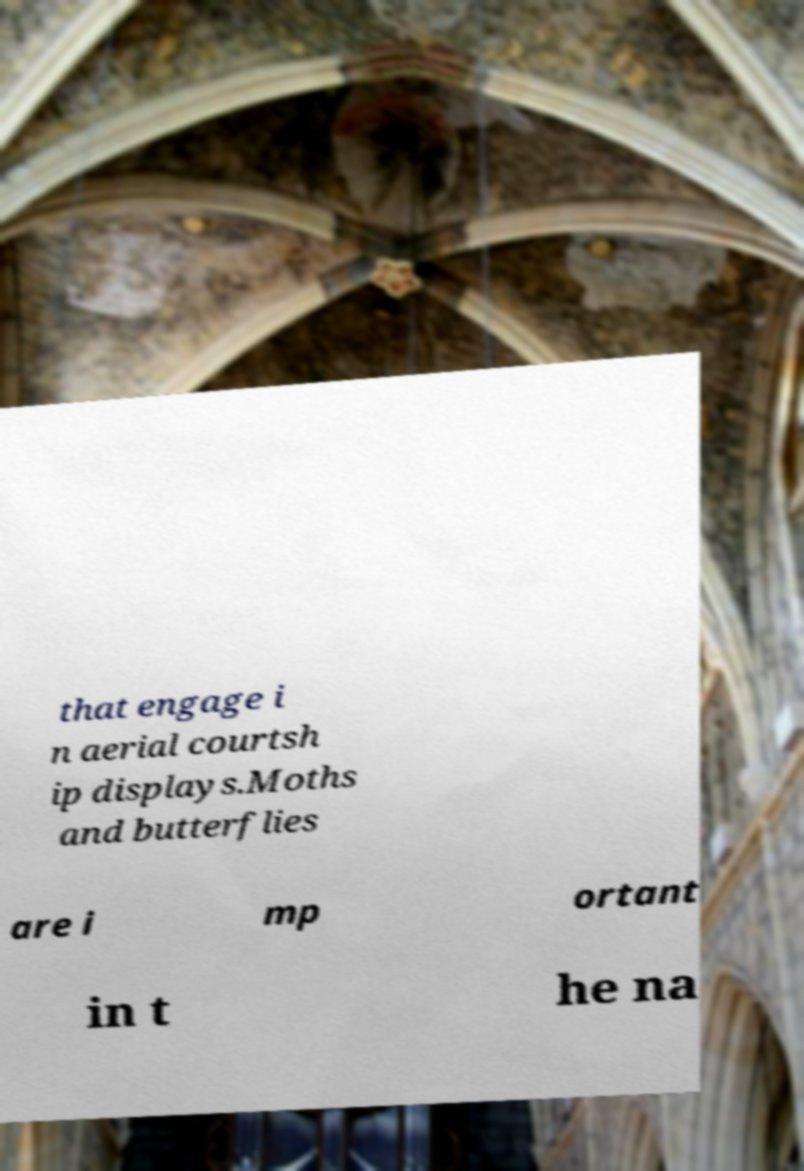Please identify and transcribe the text found in this image. that engage i n aerial courtsh ip displays.Moths and butterflies are i mp ortant in t he na 